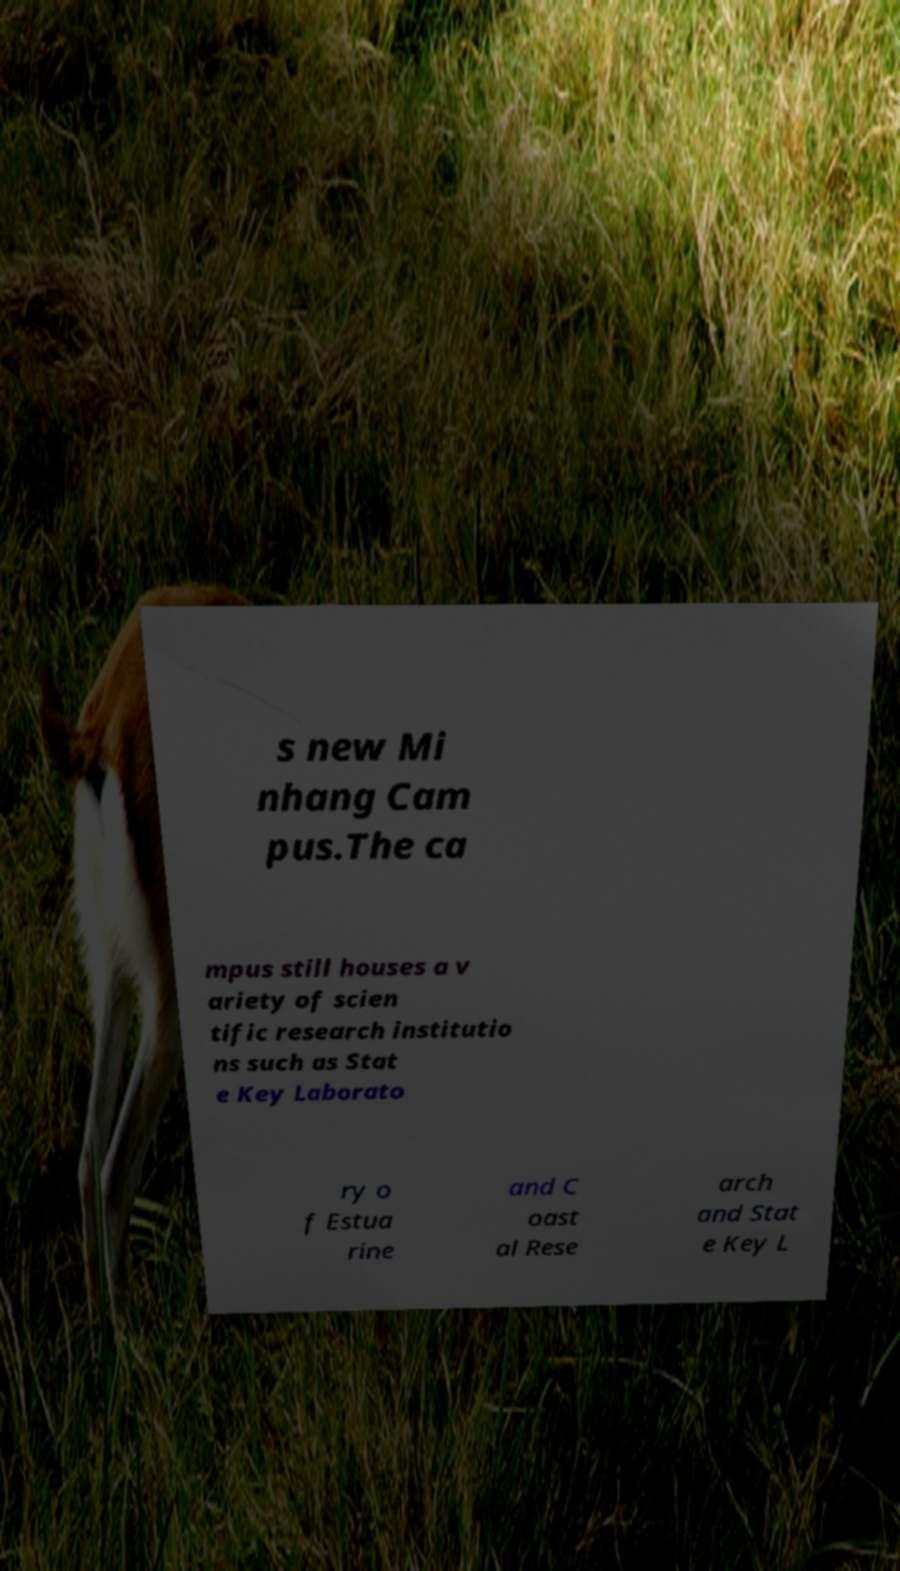For documentation purposes, I need the text within this image transcribed. Could you provide that? s new Mi nhang Cam pus.The ca mpus still houses a v ariety of scien tific research institutio ns such as Stat e Key Laborato ry o f Estua rine and C oast al Rese arch and Stat e Key L 